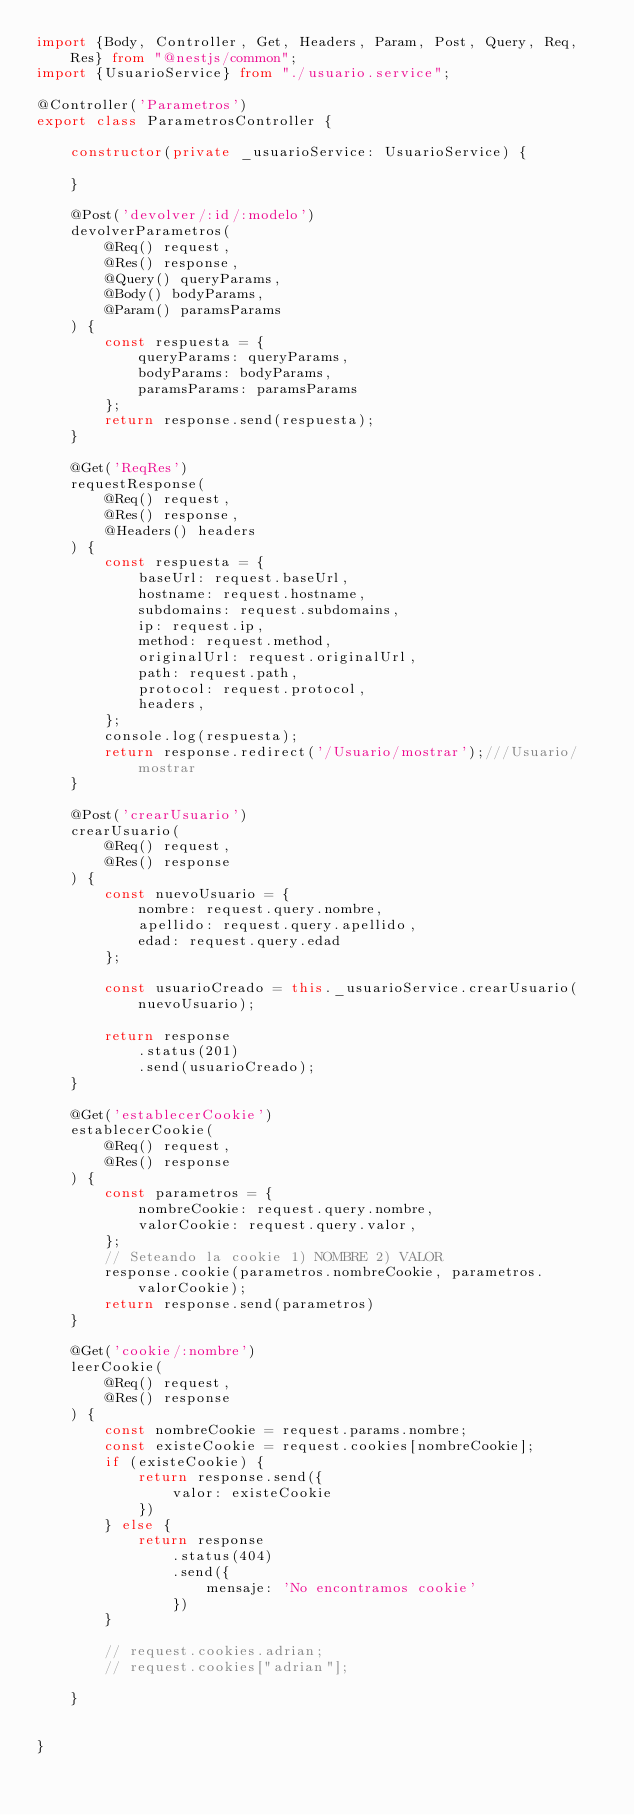Convert code to text. <code><loc_0><loc_0><loc_500><loc_500><_TypeScript_>import {Body, Controller, Get, Headers, Param, Post, Query, Req, Res} from "@nestjs/common";
import {UsuarioService} from "./usuario.service";

@Controller('Parametros')
export class ParametrosController {

    constructor(private _usuarioService: UsuarioService) {

    }

    @Post('devolver/:id/:modelo')
    devolverParametros(
        @Req() request,
        @Res() response,
        @Query() queryParams,
        @Body() bodyParams,
        @Param() paramsParams
    ) {
        const respuesta = {
            queryParams: queryParams,
            bodyParams: bodyParams,
            paramsParams: paramsParams
        };
        return response.send(respuesta);
    }

    @Get('ReqRes')
    requestResponse(
        @Req() request,
        @Res() response,
        @Headers() headers
    ) {
        const respuesta = {
            baseUrl: request.baseUrl,
            hostname: request.hostname,
            subdomains: request.subdomains,
            ip: request.ip,
            method: request.method,
            originalUrl: request.originalUrl,
            path: request.path,
            protocol: request.protocol,
            headers,
        };
        console.log(respuesta);
        return response.redirect('/Usuario/mostrar');///Usuario/mostrar
    }

    @Post('crearUsuario')
    crearUsuario(
        @Req() request,
        @Res() response
    ) {
        const nuevoUsuario = {
            nombre: request.query.nombre,
            apellido: request.query.apellido,
            edad: request.query.edad
        };

        const usuarioCreado = this._usuarioService.crearUsuario(nuevoUsuario);

        return response
            .status(201)
            .send(usuarioCreado);
    }

    @Get('establecerCookie')
    establecerCookie(
        @Req() request,
        @Res() response
    ) {
        const parametros = {
            nombreCookie: request.query.nombre,
            valorCookie: request.query.valor,
        };
        // Seteando la cookie 1) NOMBRE 2) VALOR
        response.cookie(parametros.nombreCookie, parametros.valorCookie);
        return response.send(parametros)
    }

    @Get('cookie/:nombre')
    leerCookie(
        @Req() request,
        @Res() response
    ) {
        const nombreCookie = request.params.nombre;
        const existeCookie = request.cookies[nombreCookie];
        if (existeCookie) {
            return response.send({
                valor: existeCookie
            })
        } else {
            return response
                .status(404)
                .send({
                    mensaje: 'No encontramos cookie'
                })
        }

        // request.cookies.adrian;
        // request.cookies["adrian"];

    }


}</code> 